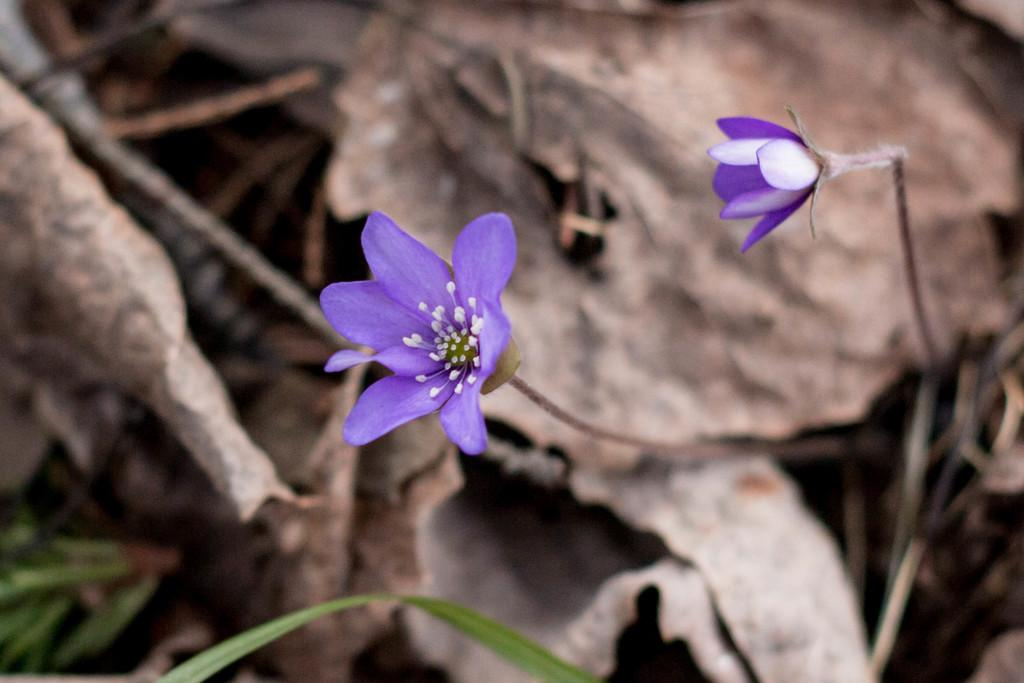What type of plants can be seen in the image? There are flowers in the image. What colors are the flowers? The flowers are in white and purple colors. What type of vegetation is present in the image besides flowers? There is grass in the image. What color is the grass? The grass is green. What can be seen in the background of the image? There are dried leaves in the background of the image. What color are the dried leaves? The dried leaves are in brown color. How many men are holding scissors in the image? There are no men or scissors present in the image. What type of animals can be seen interacting with the flowers in the image? There are no animals present in the image. 